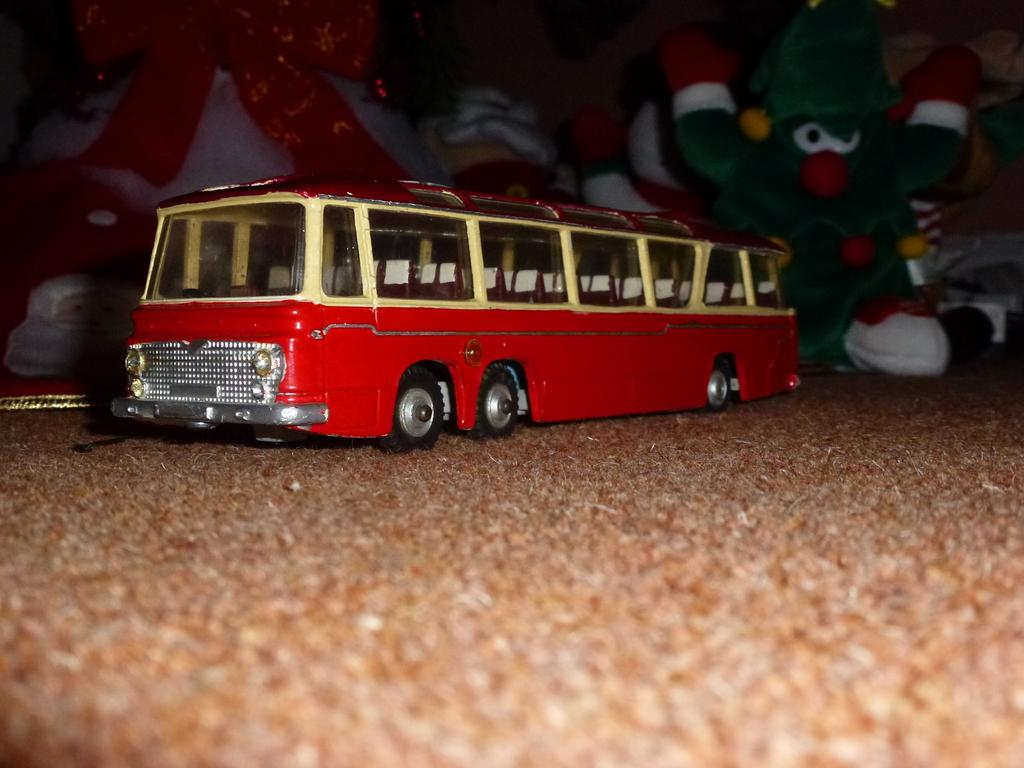What type of toy is present in the image? There is a toy bus in the image. What other types of toys can be seen in the image? There are soft toys in the image. What type of system is being used to improve the acoustics in the image? There is no mention of a system or acoustics in the image; it only features a toy bus and soft toys. 